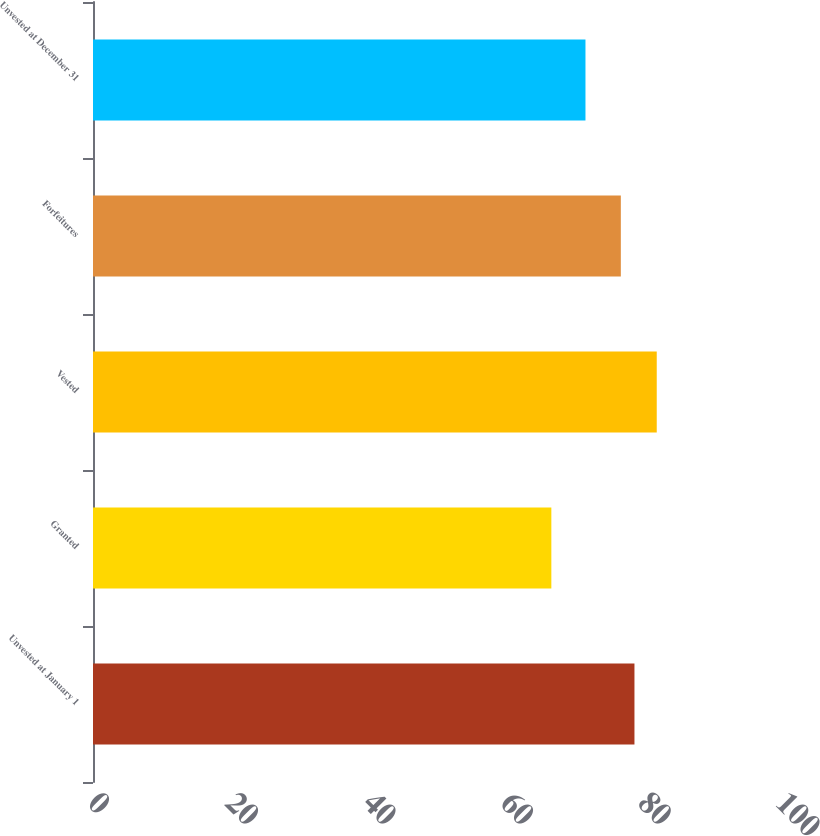Convert chart to OTSL. <chart><loc_0><loc_0><loc_500><loc_500><bar_chart><fcel>Unvested at January 1<fcel>Granted<fcel>Vested<fcel>Forfeitures<fcel>Unvested at December 31<nl><fcel>78.7<fcel>66.62<fcel>81.94<fcel>76.72<fcel>71.58<nl></chart> 